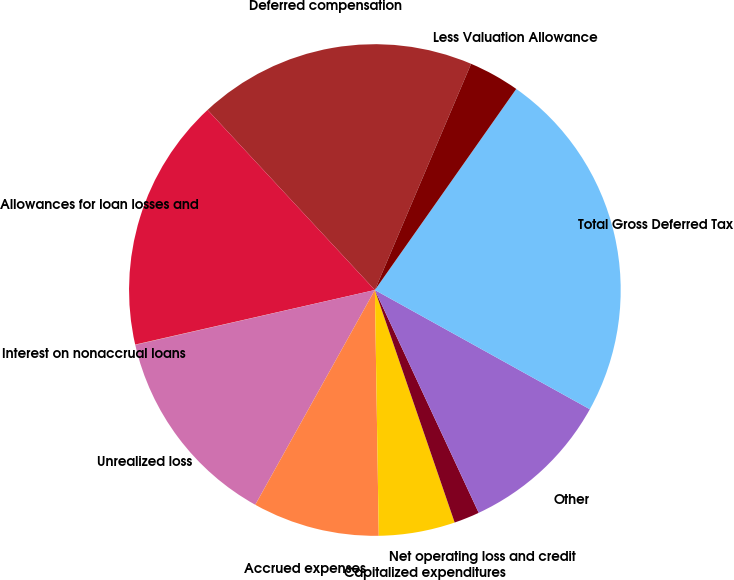<chart> <loc_0><loc_0><loc_500><loc_500><pie_chart><fcel>Deferred compensation<fcel>Allowances for loan losses and<fcel>Interest on nonaccrual loans<fcel>Unrealized loss<fcel>Accrued expenses<fcel>Capitalized expenditures<fcel>Net operating loss and credit<fcel>Other<fcel>Total Gross Deferred Tax<fcel>Less Valuation Allowance<nl><fcel>18.32%<fcel>16.65%<fcel>0.02%<fcel>13.33%<fcel>8.34%<fcel>5.01%<fcel>1.68%<fcel>10.0%<fcel>23.31%<fcel>3.35%<nl></chart> 